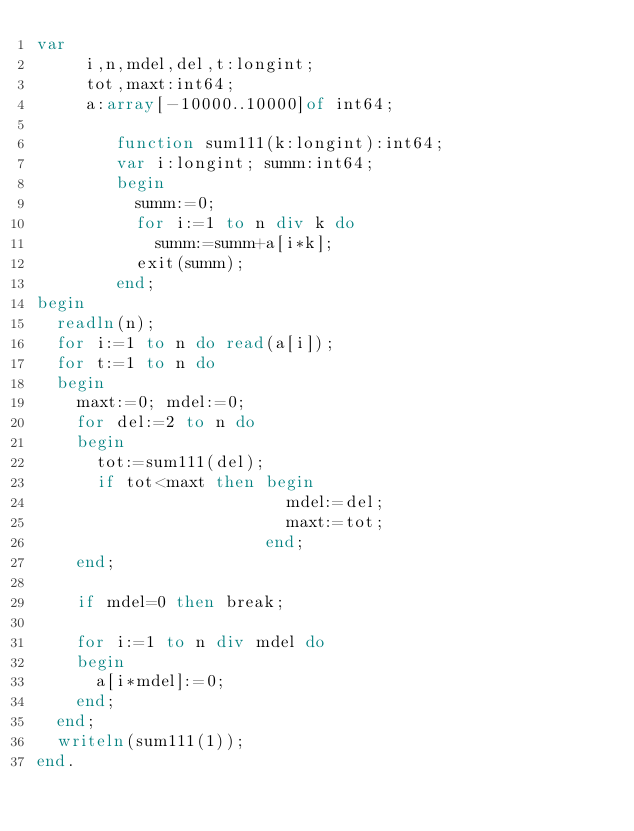<code> <loc_0><loc_0><loc_500><loc_500><_Pascal_>var
     i,n,mdel,del,t:longint;
     tot,maxt:int64;
     a:array[-10000..10000]of int64;

        function sum111(k:longint):int64;
        var i:longint; summ:int64;
        begin
          summ:=0;
          for i:=1 to n div k do
            summ:=summ+a[i*k];
          exit(summ);
        end;
begin
  readln(n);
  for i:=1 to n do read(a[i]);
  for t:=1 to n do
  begin
    maxt:=0; mdel:=0;
    for del:=2 to n do
    begin
      tot:=sum111(del);
      if tot<maxt then begin
                         mdel:=del;
                         maxt:=tot;
                       end;
    end;

    if mdel=0 then break;

    for i:=1 to n div mdel do
    begin
      a[i*mdel]:=0;
    end;
  end;
  writeln(sum111(1));
end.</code> 